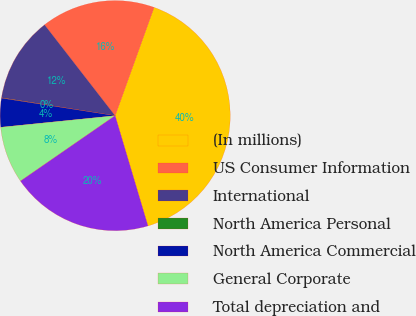<chart> <loc_0><loc_0><loc_500><loc_500><pie_chart><fcel>(In millions)<fcel>US Consumer Information<fcel>International<fcel>North America Personal<fcel>North America Commercial<fcel>General Corporate<fcel>Total depreciation and<nl><fcel>39.9%<fcel>15.99%<fcel>12.01%<fcel>0.05%<fcel>4.04%<fcel>8.02%<fcel>19.98%<nl></chart> 